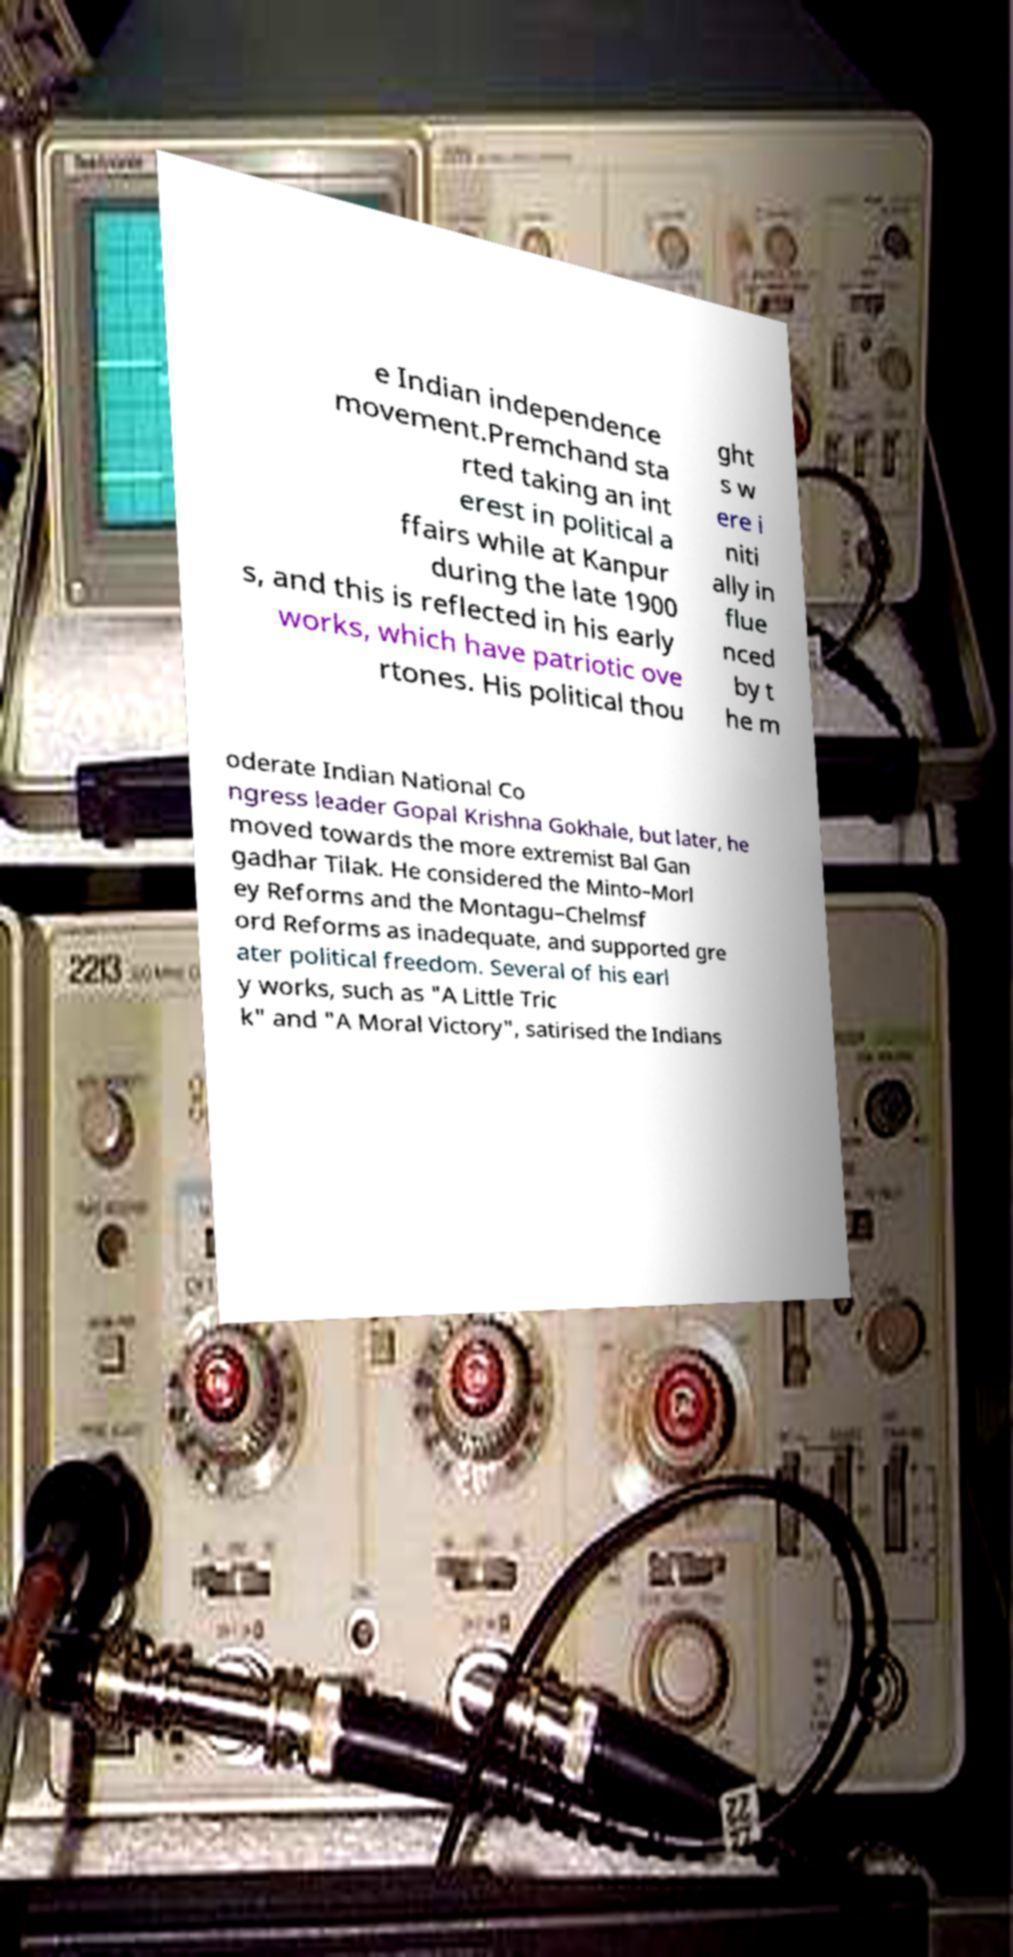Could you assist in decoding the text presented in this image and type it out clearly? e Indian independence movement.Premchand sta rted taking an int erest in political a ffairs while at Kanpur during the late 1900 s, and this is reflected in his early works, which have patriotic ove rtones. His political thou ght s w ere i niti ally in flue nced by t he m oderate Indian National Co ngress leader Gopal Krishna Gokhale, but later, he moved towards the more extremist Bal Gan gadhar Tilak. He considered the Minto–Morl ey Reforms and the Montagu–Chelmsf ord Reforms as inadequate, and supported gre ater political freedom. Several of his earl y works, such as "A Little Tric k" and "A Moral Victory", satirised the Indians 